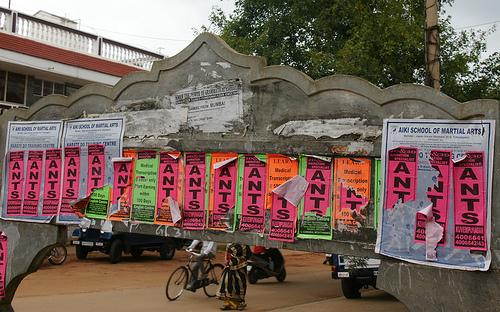Are people riding bikes?
Be succinct. Yes. Are the signs blocking everyone?
Short answer required. Yes. What is the big word written on the pink flyers?
Short answer required. Ants. Is there more than 10 bikes?
Short answer required. No. 